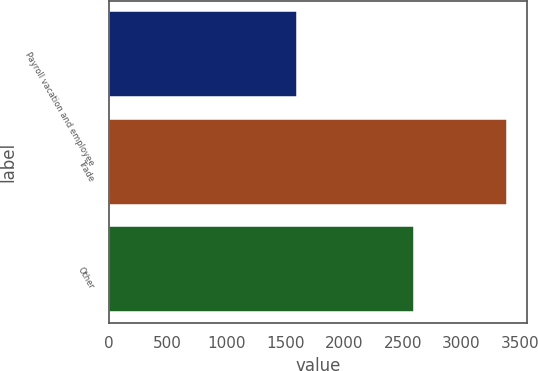<chart> <loc_0><loc_0><loc_500><loc_500><bar_chart><fcel>Payroll vacation and employee<fcel>Trade<fcel>Other<nl><fcel>1597<fcel>3389<fcel>2593<nl></chart> 